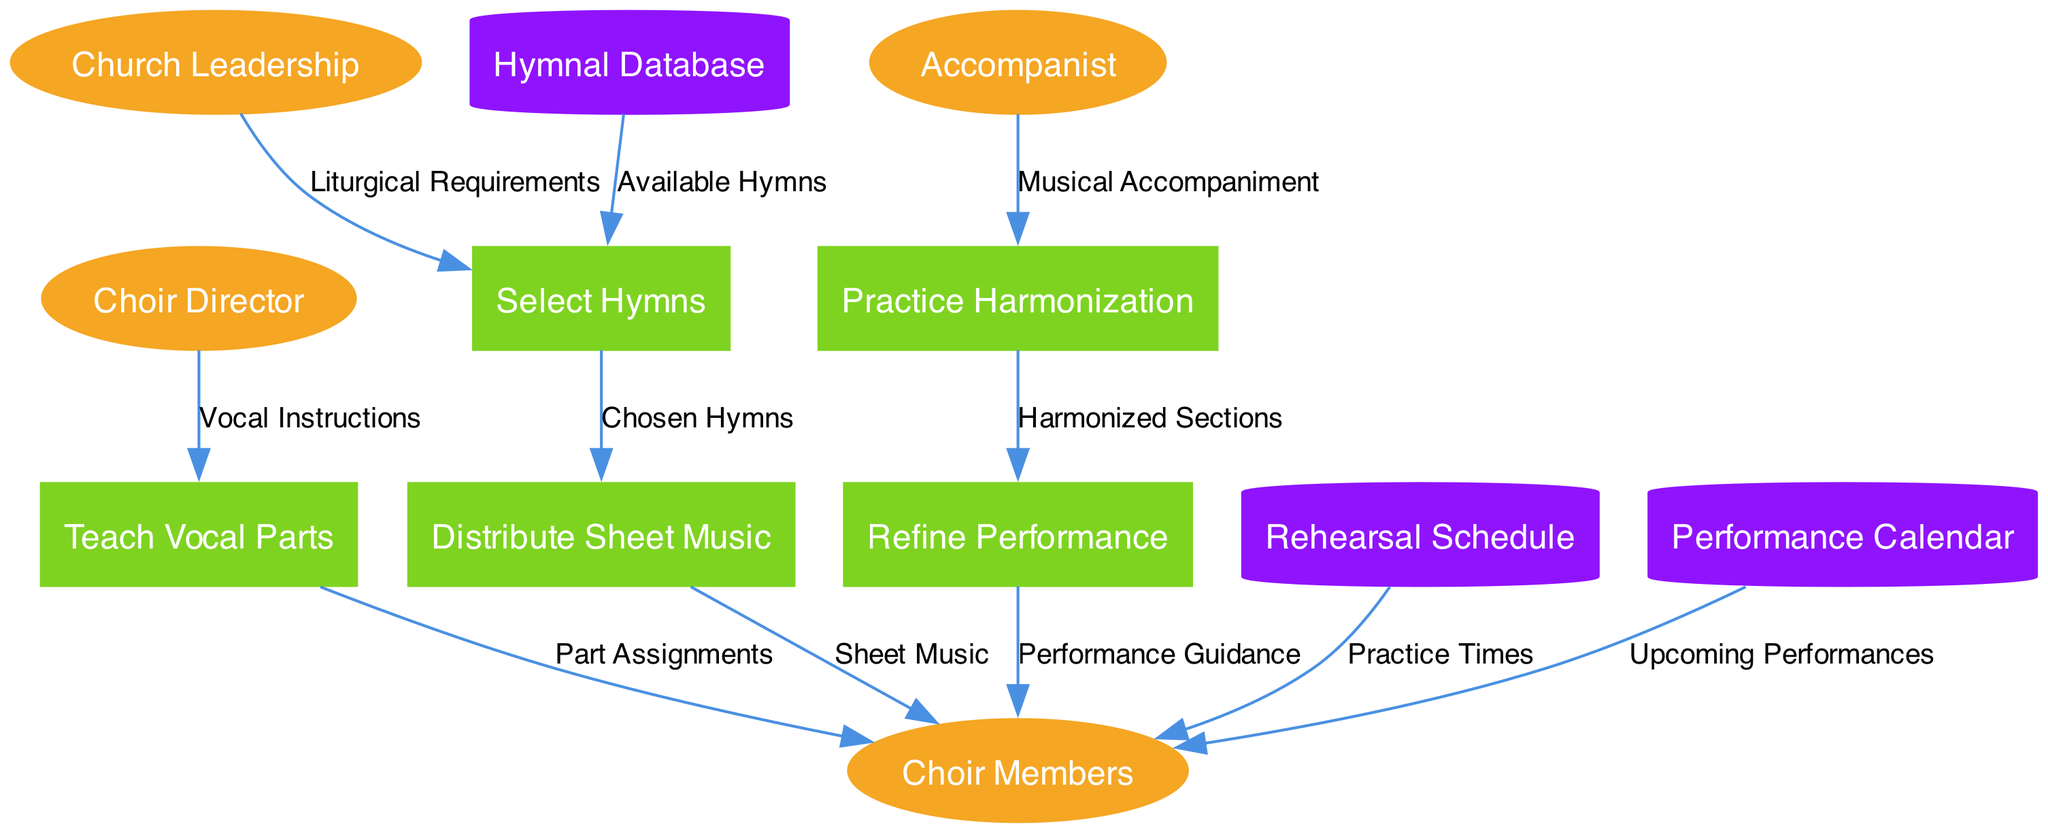What are the external entities in this diagram? The external entities are the points of interaction with the processes within the diagram. To find them, we can look at the section labeled "external_entities," which lists members like Choir Director, Choir Members, Accompanist, and Church Leadership.
Answer: Choir Director, Choir Members, Accompanist, Church Leadership How many processes are represented in the diagram? The number of processes can be counted in the "processes" section of the diagram data. There are five processes listed: Select Hymns, Distribute Sheet Music, Teach Vocal Parts, Practice Harmonization, and Refine Performance.
Answer: 5 Which process follows "Teach Vocal Parts"? To determine what follows "Teach Vocal Parts," we can look for the data flows that originate from it. The flow indicates that "Teach Vocal Parts" leads to "Choir Members" with "Part Assignments." Therefore, "Practice Harmonization" is the next process in sequence.
Answer: Practice Harmonization What information does "Church Leadership" provide to "Select Hymns"? According to the data flow diagram, "Church Leadership" sends "Liturgical Requirements" to "Select Hymns." This relationship illustrates how the church leadership's guidelines influence hymn selection.
Answer: Liturgical Requirements Which data store is associated with the choir members' practice times? The data flow indicates that "Rehearsal Schedule" is the store that provides "Practice Times" to "Choir Members." Therefore, the relevant data store for this information is "Rehearsal Schedule."
Answer: Rehearsal Schedule Describe the flow of information from "Distribute Sheet Music" to "Choir Members." The flow initiates with "Distribute Sheet Music," which then sends "Sheet Music" directly to "Choir Members." This highlights how the sheet music is given as a tangible resource for members to practice.
Answer: Sheet Music How does "Accompanist" contribute to the rehearsal process? The "Accompanist" provides "Musical Accompaniment" to the "Practice Harmonization" process. This indicates the role of the accompanist in enhancing vocal practice through instrumental support.
Answer: Musical Accompaniment What is the final interaction process that outputs to "Choir Members"? The last process that provides output to "Choir Members" is "Refine Performance," which gives "Performance Guidance." This indicates that the choir members receive feedback at the end of the rehearsal process.
Answer: Performance Guidance Which process is linked to "Hymnal Database"? To find this, we observe that "Hymnal Database" is linked to the "Select Hymns" process, which receives "Available Hymns" from the database. This shows the database's role in hymn selection.
Answer: Select Hymns 